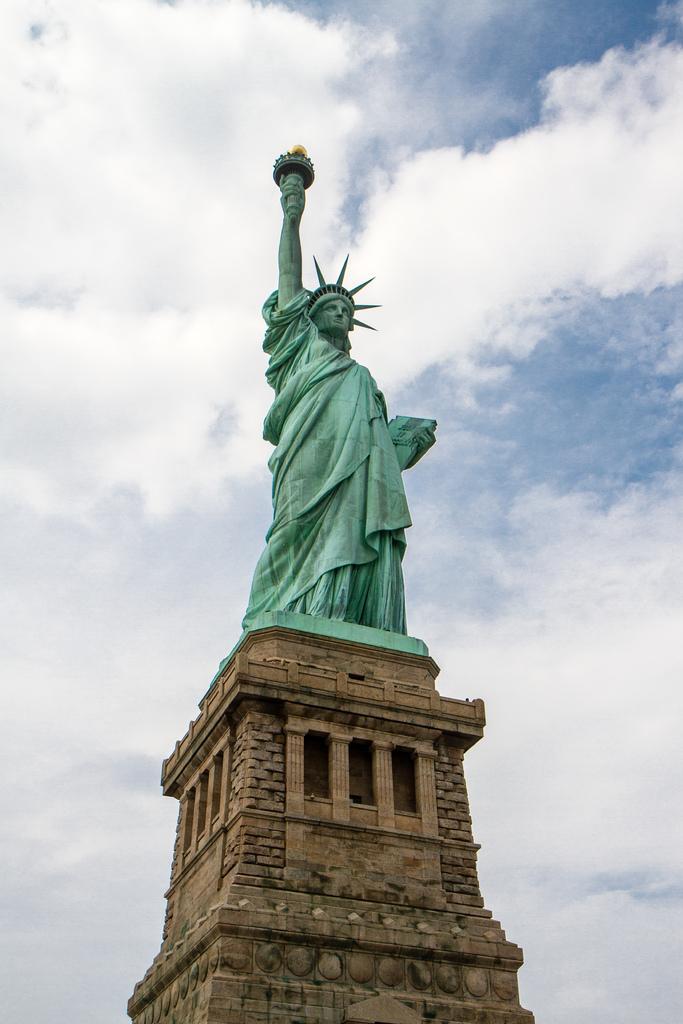Please provide a concise description of this image. In this picture I can see the statue of Liberty and I can see a blue cloudy sky. 